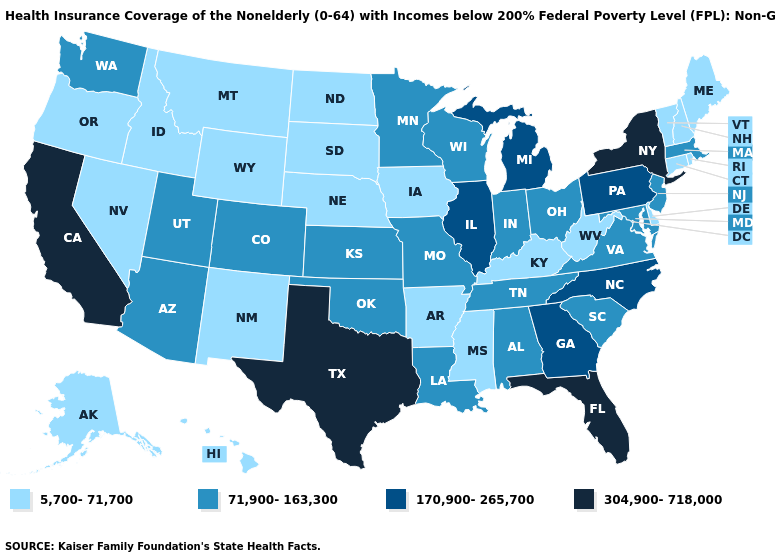What is the value of Alaska?
Concise answer only. 5,700-71,700. Does Kansas have a lower value than Georgia?
Answer briefly. Yes. Does Tennessee have a higher value than Hawaii?
Concise answer only. Yes. What is the value of Utah?
Write a very short answer. 71,900-163,300. What is the lowest value in the MidWest?
Short answer required. 5,700-71,700. Does Hawaii have the same value as Alaska?
Quick response, please. Yes. Name the states that have a value in the range 71,900-163,300?
Keep it brief. Alabama, Arizona, Colorado, Indiana, Kansas, Louisiana, Maryland, Massachusetts, Minnesota, Missouri, New Jersey, Ohio, Oklahoma, South Carolina, Tennessee, Utah, Virginia, Washington, Wisconsin. How many symbols are there in the legend?
Concise answer only. 4. What is the value of North Carolina?
Keep it brief. 170,900-265,700. Among the states that border Arkansas , does Texas have the highest value?
Be succinct. Yes. Name the states that have a value in the range 304,900-718,000?
Concise answer only. California, Florida, New York, Texas. What is the lowest value in the USA?
Be succinct. 5,700-71,700. Does the first symbol in the legend represent the smallest category?
Write a very short answer. Yes. Name the states that have a value in the range 170,900-265,700?
Give a very brief answer. Georgia, Illinois, Michigan, North Carolina, Pennsylvania. What is the value of Connecticut?
Short answer required. 5,700-71,700. 